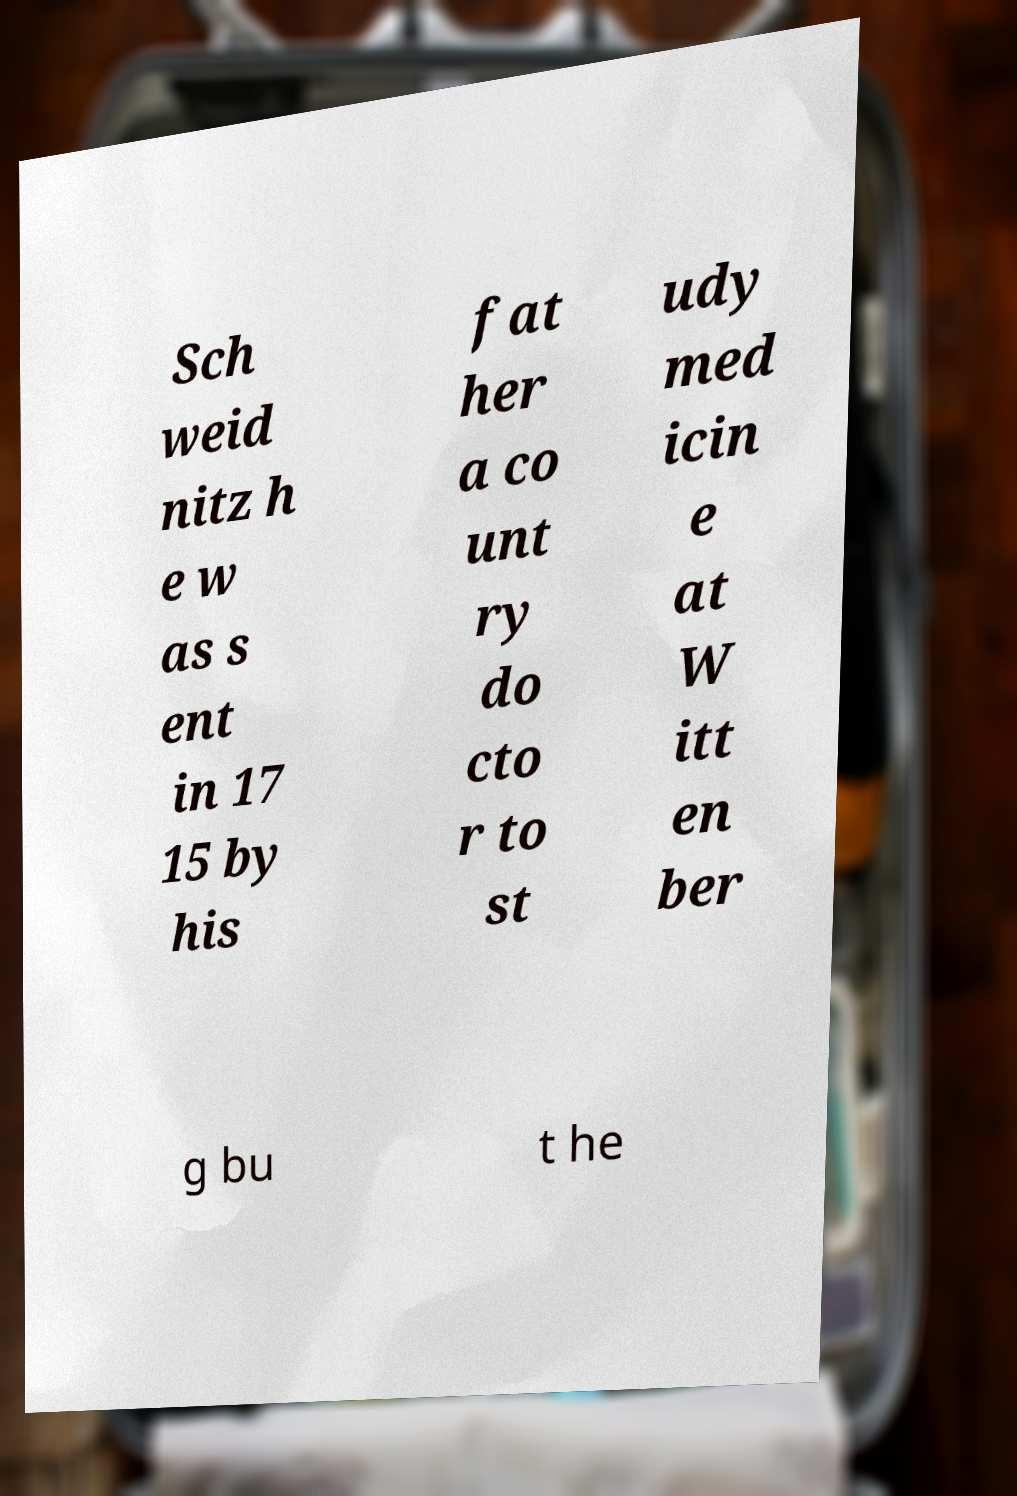Could you extract and type out the text from this image? Sch weid nitz h e w as s ent in 17 15 by his fat her a co unt ry do cto r to st udy med icin e at W itt en ber g bu t he 